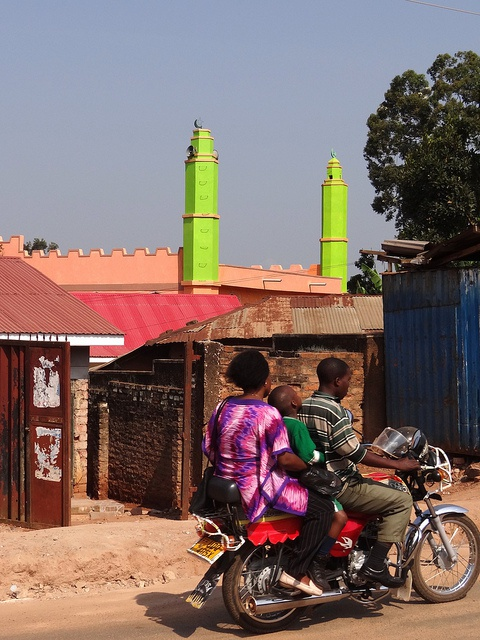Describe the objects in this image and their specific colors. I can see motorcycle in darkgray, black, maroon, and gray tones, people in darkgray, black, maroon, purple, and violet tones, people in darkgray, black, maroon, and gray tones, people in darkgray, black, maroon, darkgreen, and brown tones, and handbag in darkgray, black, maroon, and brown tones in this image. 